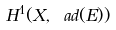Convert formula to latex. <formula><loc_0><loc_0><loc_500><loc_500>H ^ { 1 } ( X , \ a d ( E ) )</formula> 